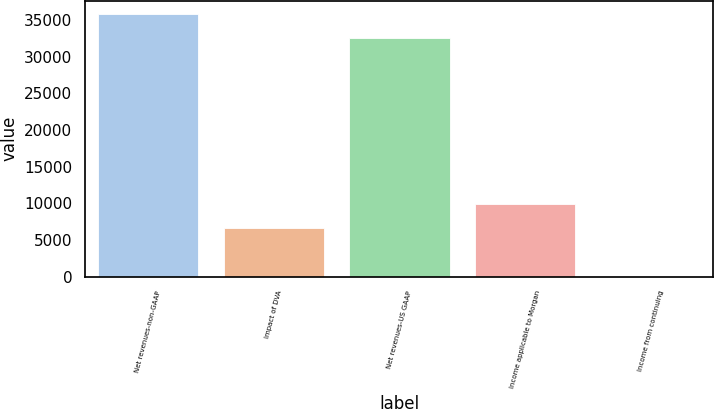Convert chart to OTSL. <chart><loc_0><loc_0><loc_500><loc_500><bar_chart><fcel>Net revenues-non-GAAP<fcel>Impact of DVA<fcel>Net revenues-US GAAP<fcel>Income applicable to Morgan<fcel>Income from continuing<nl><fcel>35810.3<fcel>6635.9<fcel>32493<fcel>9953.16<fcel>1.38<nl></chart> 